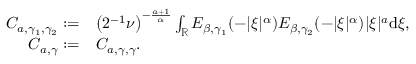<formula> <loc_0><loc_0><loc_500><loc_500>\begin{array} { r l } { C _ { a , \gamma _ { 1 } , \gamma _ { 2 } } \colon = } & { \left ( 2 ^ { - 1 } \nu \right ) ^ { - \frac { a + 1 } { \alpha } } \int _ { \mathbb { R } } E _ { \beta , \gamma _ { 1 } } ( - | \xi | ^ { \alpha } ) E _ { \beta , \gamma _ { 2 } } ( - | \xi | ^ { \alpha } ) | \xi | ^ { a } { d } \xi , } \\ { C _ { a , \gamma } \colon = } & { C _ { a , \gamma , \gamma } . } \end{array}</formula> 